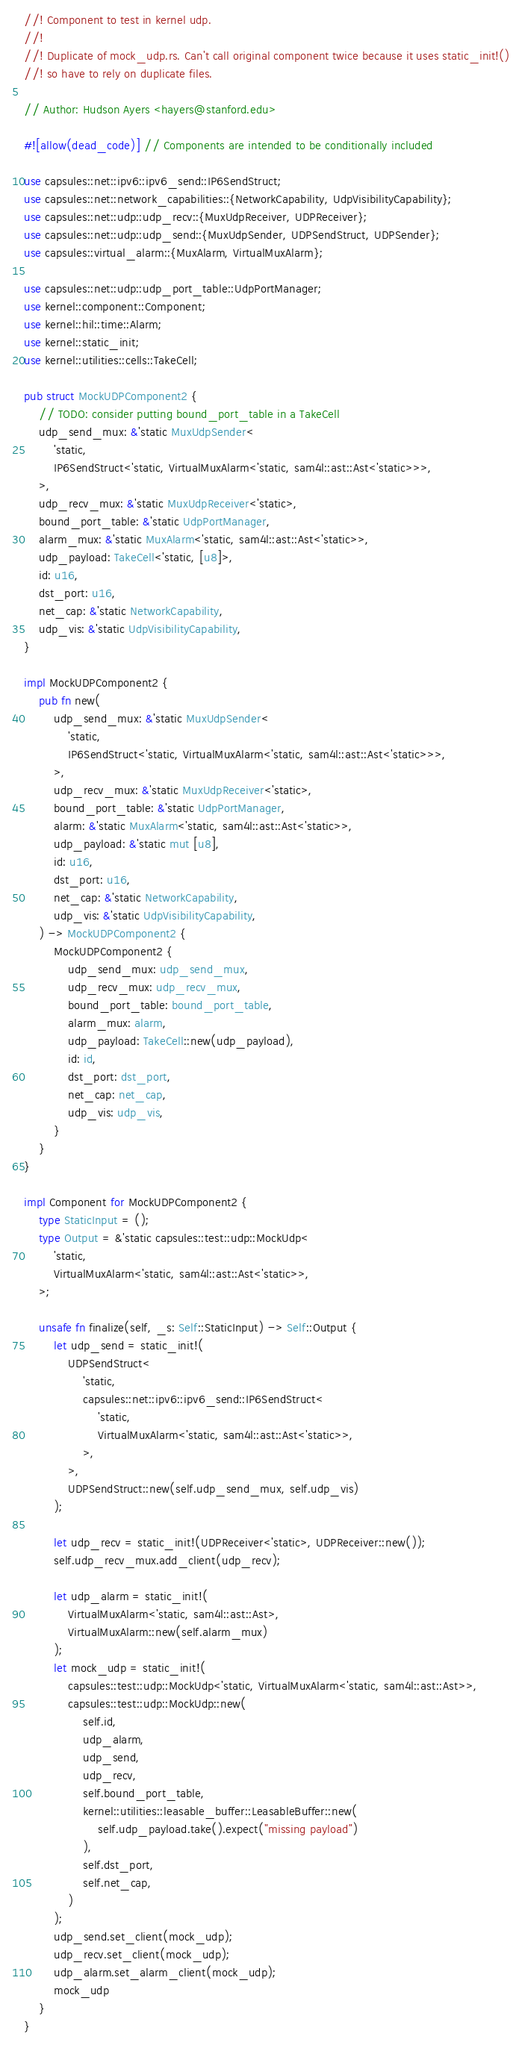<code> <loc_0><loc_0><loc_500><loc_500><_Rust_>//! Component to test in kernel udp.
//!
//! Duplicate of mock_udp.rs. Can't call original component twice because it uses static_init!()
//! so have to rely on duplicate files.

// Author: Hudson Ayers <hayers@stanford.edu>

#![allow(dead_code)] // Components are intended to be conditionally included

use capsules::net::ipv6::ipv6_send::IP6SendStruct;
use capsules::net::network_capabilities::{NetworkCapability, UdpVisibilityCapability};
use capsules::net::udp::udp_recv::{MuxUdpReceiver, UDPReceiver};
use capsules::net::udp::udp_send::{MuxUdpSender, UDPSendStruct, UDPSender};
use capsules::virtual_alarm::{MuxAlarm, VirtualMuxAlarm};

use capsules::net::udp::udp_port_table::UdpPortManager;
use kernel::component::Component;
use kernel::hil::time::Alarm;
use kernel::static_init;
use kernel::utilities::cells::TakeCell;

pub struct MockUDPComponent2 {
    // TODO: consider putting bound_port_table in a TakeCell
    udp_send_mux: &'static MuxUdpSender<
        'static,
        IP6SendStruct<'static, VirtualMuxAlarm<'static, sam4l::ast::Ast<'static>>>,
    >,
    udp_recv_mux: &'static MuxUdpReceiver<'static>,
    bound_port_table: &'static UdpPortManager,
    alarm_mux: &'static MuxAlarm<'static, sam4l::ast::Ast<'static>>,
    udp_payload: TakeCell<'static, [u8]>,
    id: u16,
    dst_port: u16,
    net_cap: &'static NetworkCapability,
    udp_vis: &'static UdpVisibilityCapability,
}

impl MockUDPComponent2 {
    pub fn new(
        udp_send_mux: &'static MuxUdpSender<
            'static,
            IP6SendStruct<'static, VirtualMuxAlarm<'static, sam4l::ast::Ast<'static>>>,
        >,
        udp_recv_mux: &'static MuxUdpReceiver<'static>,
        bound_port_table: &'static UdpPortManager,
        alarm: &'static MuxAlarm<'static, sam4l::ast::Ast<'static>>,
        udp_payload: &'static mut [u8],
        id: u16,
        dst_port: u16,
        net_cap: &'static NetworkCapability,
        udp_vis: &'static UdpVisibilityCapability,
    ) -> MockUDPComponent2 {
        MockUDPComponent2 {
            udp_send_mux: udp_send_mux,
            udp_recv_mux: udp_recv_mux,
            bound_port_table: bound_port_table,
            alarm_mux: alarm,
            udp_payload: TakeCell::new(udp_payload),
            id: id,
            dst_port: dst_port,
            net_cap: net_cap,
            udp_vis: udp_vis,
        }
    }
}

impl Component for MockUDPComponent2 {
    type StaticInput = ();
    type Output = &'static capsules::test::udp::MockUdp<
        'static,
        VirtualMuxAlarm<'static, sam4l::ast::Ast<'static>>,
    >;

    unsafe fn finalize(self, _s: Self::StaticInput) -> Self::Output {
        let udp_send = static_init!(
            UDPSendStruct<
                'static,
                capsules::net::ipv6::ipv6_send::IP6SendStruct<
                    'static,
                    VirtualMuxAlarm<'static, sam4l::ast::Ast<'static>>,
                >,
            >,
            UDPSendStruct::new(self.udp_send_mux, self.udp_vis)
        );

        let udp_recv = static_init!(UDPReceiver<'static>, UDPReceiver::new());
        self.udp_recv_mux.add_client(udp_recv);

        let udp_alarm = static_init!(
            VirtualMuxAlarm<'static, sam4l::ast::Ast>,
            VirtualMuxAlarm::new(self.alarm_mux)
        );
        let mock_udp = static_init!(
            capsules::test::udp::MockUdp<'static, VirtualMuxAlarm<'static, sam4l::ast::Ast>>,
            capsules::test::udp::MockUdp::new(
                self.id,
                udp_alarm,
                udp_send,
                udp_recv,
                self.bound_port_table,
                kernel::utilities::leasable_buffer::LeasableBuffer::new(
                    self.udp_payload.take().expect("missing payload")
                ),
                self.dst_port,
                self.net_cap,
            )
        );
        udp_send.set_client(mock_udp);
        udp_recv.set_client(mock_udp);
        udp_alarm.set_alarm_client(mock_udp);
        mock_udp
    }
}
</code> 